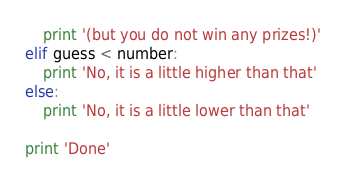<code> <loc_0><loc_0><loc_500><loc_500><_Python_>    print '(but you do not win any prizes!)'
elif guess < number:
    print 'No, it is a little higher than that'
else:
    print 'No, it is a little lower than that'

print 'Done'
</code> 